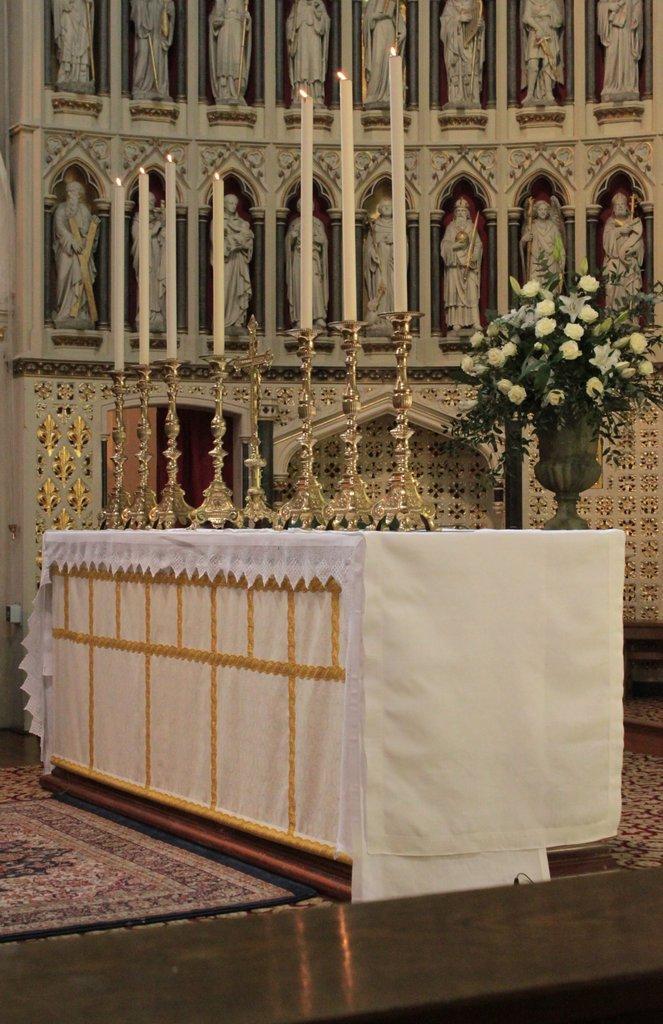Could you give a brief overview of what you see in this image? In this image we can see there are many candles on the table ,placed on after the other. 